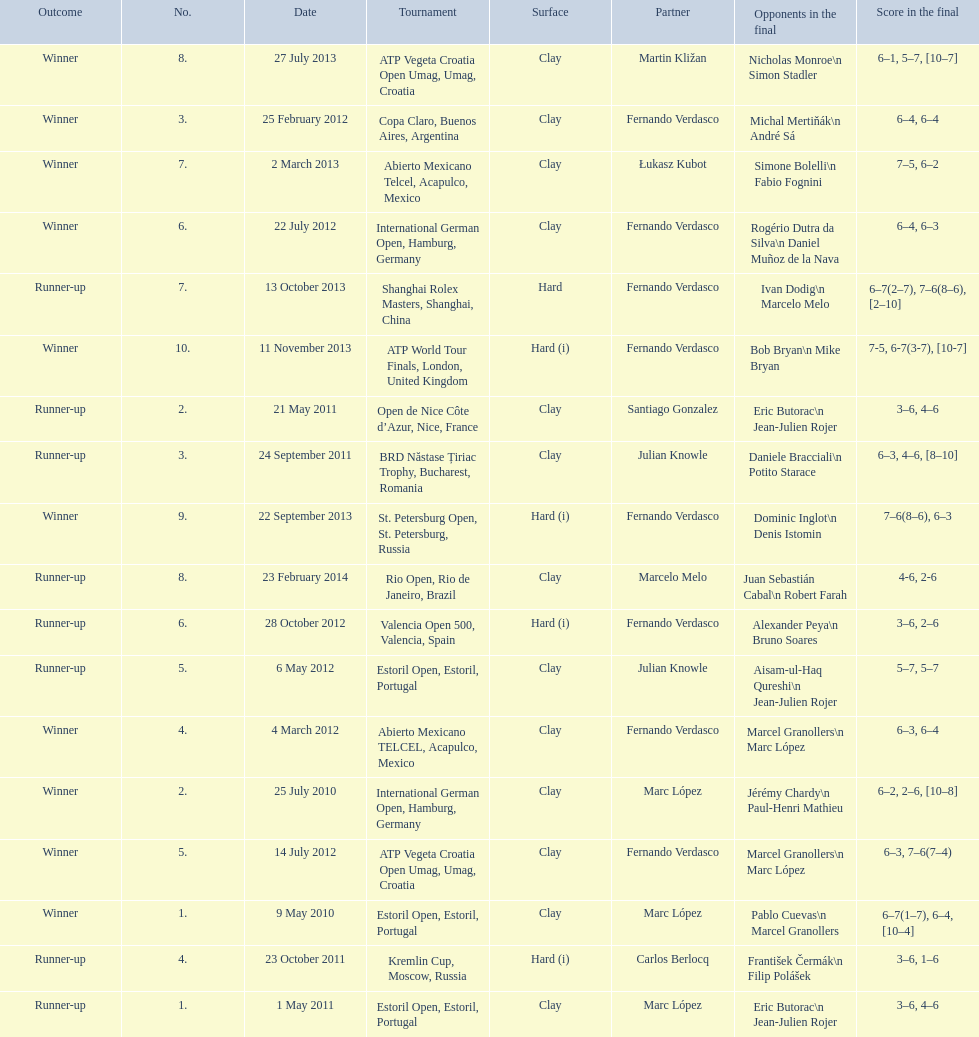How many runner-ups at most are listed? 8. 